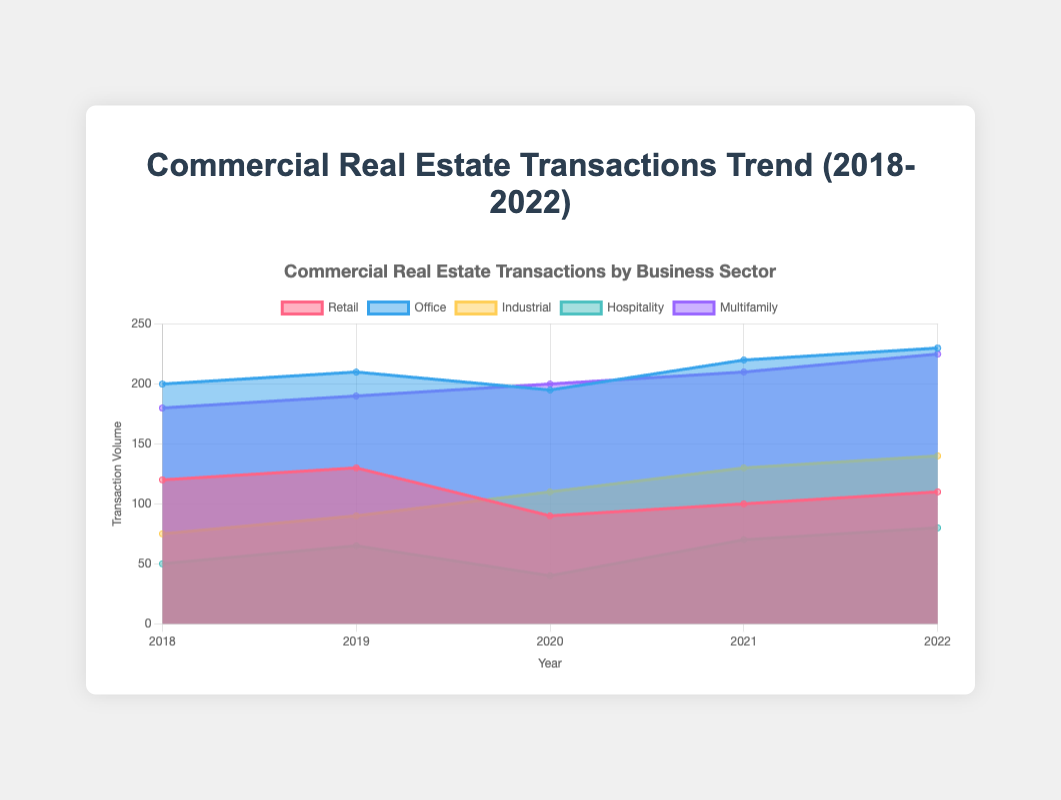What's the general trend in the volume of office transactions from 2018 to 2022? The volume of office transactions has generally increased over the years, starting from 200 in 2018 and reaching 230 in 2022.
Answer: Increasing Which sector experienced a noticeable decline in transaction volume in 2020 compared to 2019? Retail transactions dropped significantly from 130 in 2019 to 90 in 2020.
Answer: Retail Between which two consecutive years did the hospitality sector see the largest increase in transactions? The hospitality sector saw the largest increase in transactions between 2020 and 2021, going from 40 to 70.
Answer: 2020-2021 How did the industrial sector's transaction volume change from 2018 to 2022? The industrial sector's transaction volume increased from 75 in 2018 to 140 in 2022.
Answer: Increased Which sector had the highest transaction volume in any given year during the period 2018-2022, and what was the value? The office sector had the highest transaction volume with 230 transactions in 2022.
Answer: Office, 230 In which year did the multifamily sector see the highest transaction volume? The multifamily sector saw the highest transaction volume in 2022 with 225 transactions.
Answer: 2022 Compare the transaction volumes of the office sector and the retail sector in 2021. Which was higher and by how much? In 2021, the office sector had 220 transactions, while the retail sector had 100 transactions. The office sector had 120 more transactions.
Answer: Office by 120 What was the combined transaction volume of the hospitality and industrial sectors in 2019? The hospitality sector had 65 transactions and the industrial sector had 90 transactions in 2019. Combined, they had 65 + 90 = 155 transactions.
Answer: 155 What is the average transaction volume for the multifamily sector from 2018 to 2022? The transaction volumes for the multifamily sector are 180, 190, 200, 210, 225. The sum is 1005, and there are 5 years. So, the average is 1005 / 5 = 201.
Answer: 201 